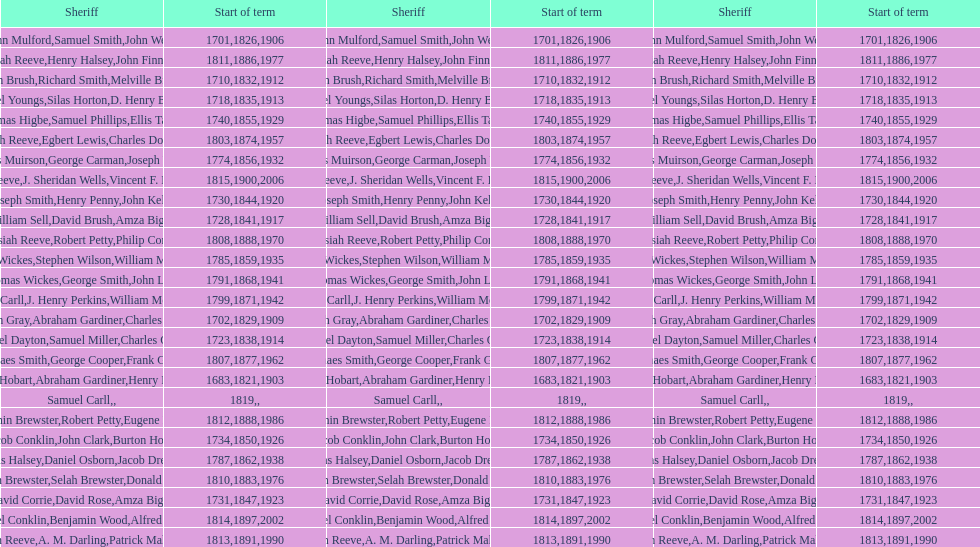How many sheriff's have the last name biggs? 1. 